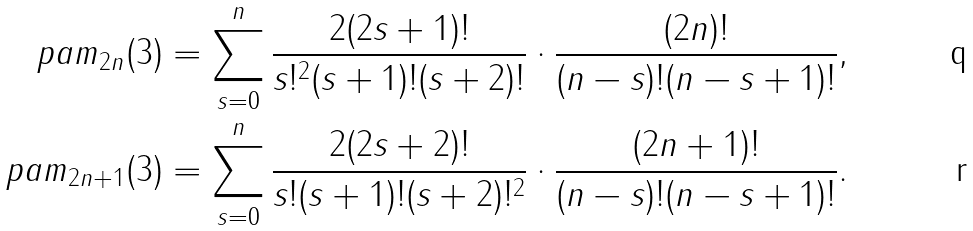<formula> <loc_0><loc_0><loc_500><loc_500>\ p a m _ { 2 n } ( 3 ) & = \sum _ { s = 0 } ^ { n } \frac { 2 ( 2 s + 1 ) ! } { s ! ^ { 2 } ( s + 1 ) ! ( s + 2 ) ! } \cdot \frac { ( 2 n ) ! } { ( n - s ) ! ( n - s + 1 ) ! } , \\ \ p a m _ { 2 n + 1 } ( 3 ) & = \sum _ { s = 0 } ^ { n } \frac { 2 ( 2 s + 2 ) ! } { s ! ( s + 1 ) ! ( s + 2 ) ! ^ { 2 } } \cdot \frac { ( 2 n + 1 ) ! } { ( n - s ) ! ( n - s + 1 ) ! } .</formula> 